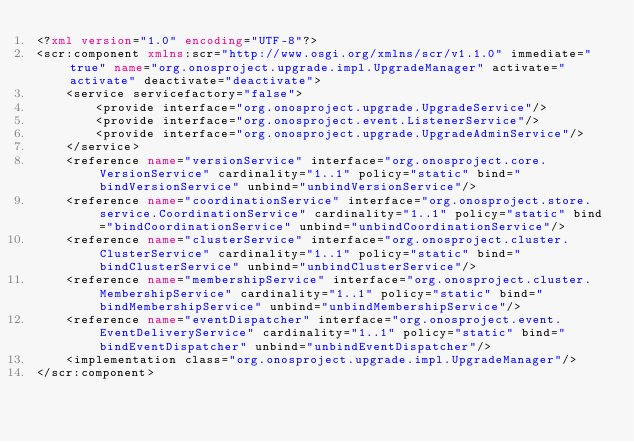Convert code to text. <code><loc_0><loc_0><loc_500><loc_500><_XML_><?xml version="1.0" encoding="UTF-8"?>
<scr:component xmlns:scr="http://www.osgi.org/xmlns/scr/v1.1.0" immediate="true" name="org.onosproject.upgrade.impl.UpgradeManager" activate="activate" deactivate="deactivate">
    <service servicefactory="false">
        <provide interface="org.onosproject.upgrade.UpgradeService"/>
        <provide interface="org.onosproject.event.ListenerService"/>
        <provide interface="org.onosproject.upgrade.UpgradeAdminService"/>
    </service>
    <reference name="versionService" interface="org.onosproject.core.VersionService" cardinality="1..1" policy="static" bind="bindVersionService" unbind="unbindVersionService"/>
    <reference name="coordinationService" interface="org.onosproject.store.service.CoordinationService" cardinality="1..1" policy="static" bind="bindCoordinationService" unbind="unbindCoordinationService"/>
    <reference name="clusterService" interface="org.onosproject.cluster.ClusterService" cardinality="1..1" policy="static" bind="bindClusterService" unbind="unbindClusterService"/>
    <reference name="membershipService" interface="org.onosproject.cluster.MembershipService" cardinality="1..1" policy="static" bind="bindMembershipService" unbind="unbindMembershipService"/>
    <reference name="eventDispatcher" interface="org.onosproject.event.EventDeliveryService" cardinality="1..1" policy="static" bind="bindEventDispatcher" unbind="unbindEventDispatcher"/>
    <implementation class="org.onosproject.upgrade.impl.UpgradeManager"/>
</scr:component>
</code> 